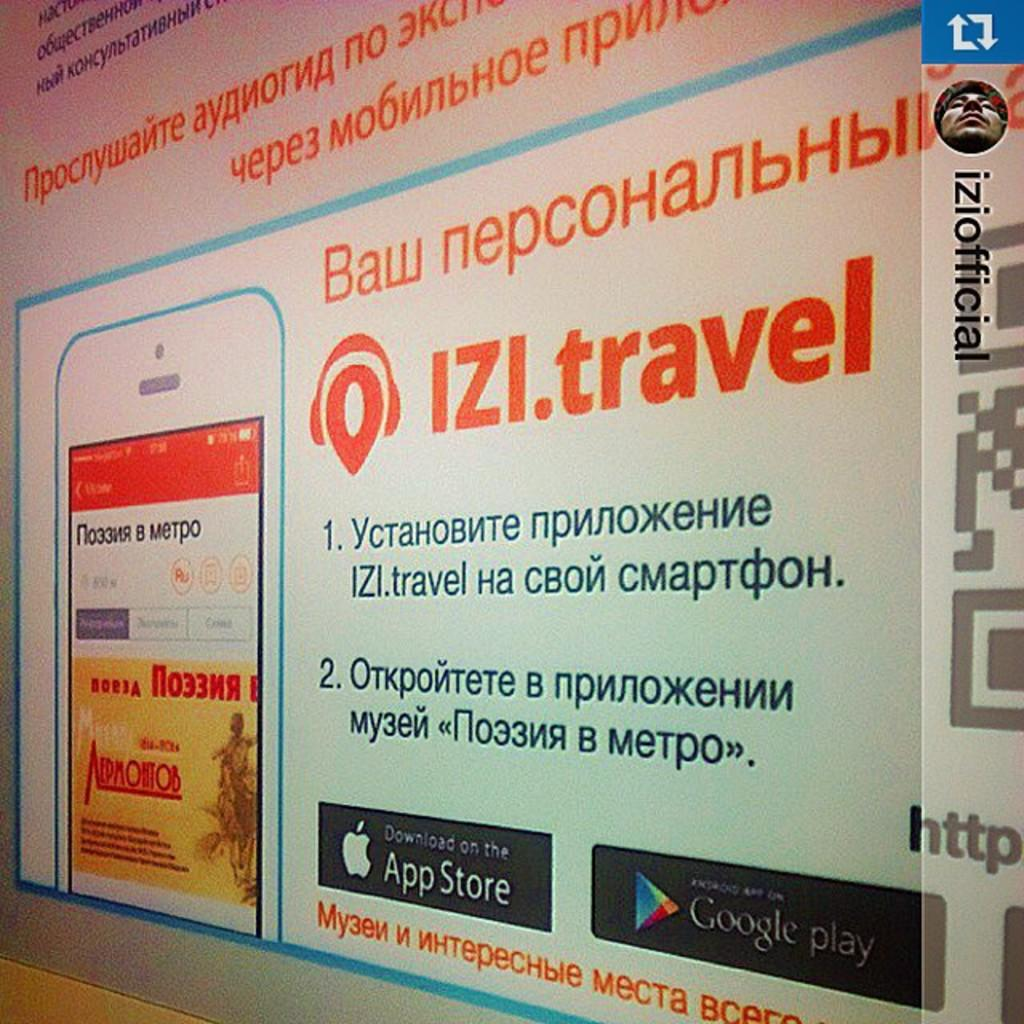<image>
Share a concise interpretation of the image provided. An app is advertised as being available on both the Apple App Store and on Google Play. 